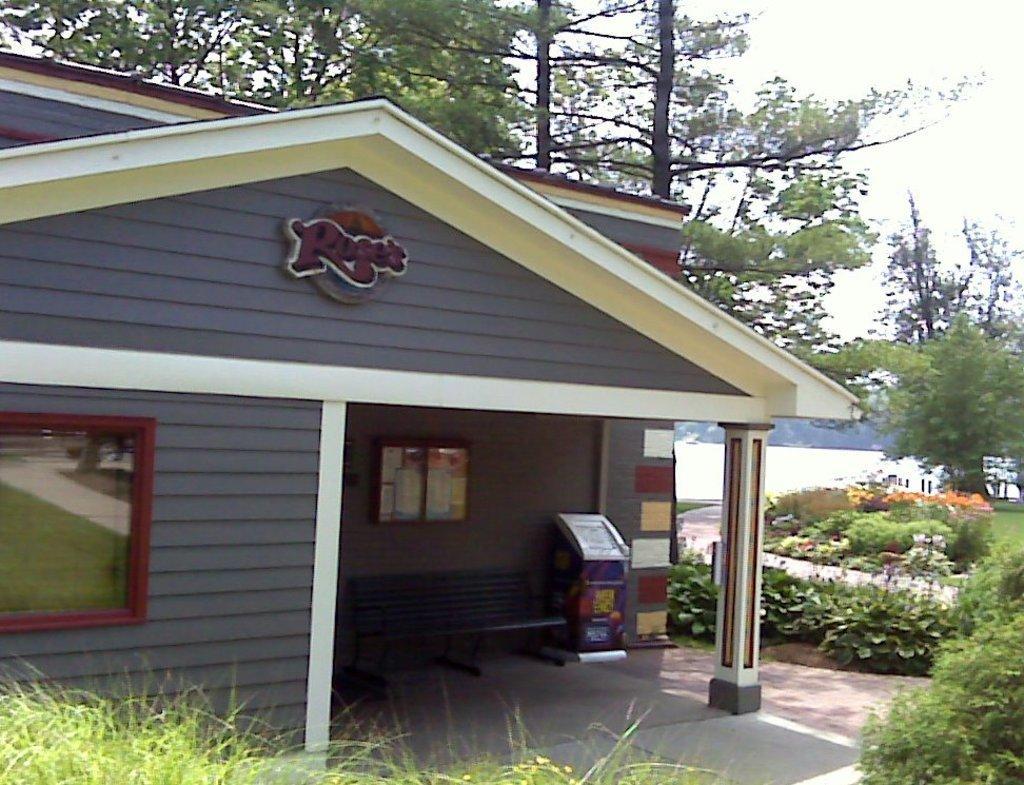How would you summarize this image in a sentence or two? In the picture I can see the house. I can see the metal bench on the floor. I can see the green grass at the bottom of the picture. I can see the flowering plants and trees on the right side. I can see the wooden glass board on the wall on the left side. 